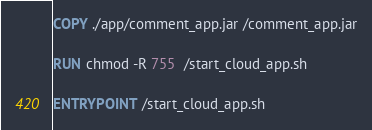Convert code to text. <code><loc_0><loc_0><loc_500><loc_500><_Dockerfile_>COPY ./app/comment_app.jar /comment_app.jar

RUN chmod -R 755  /start_cloud_app.sh

ENTRYPOINT /start_cloud_app.sh


</code> 